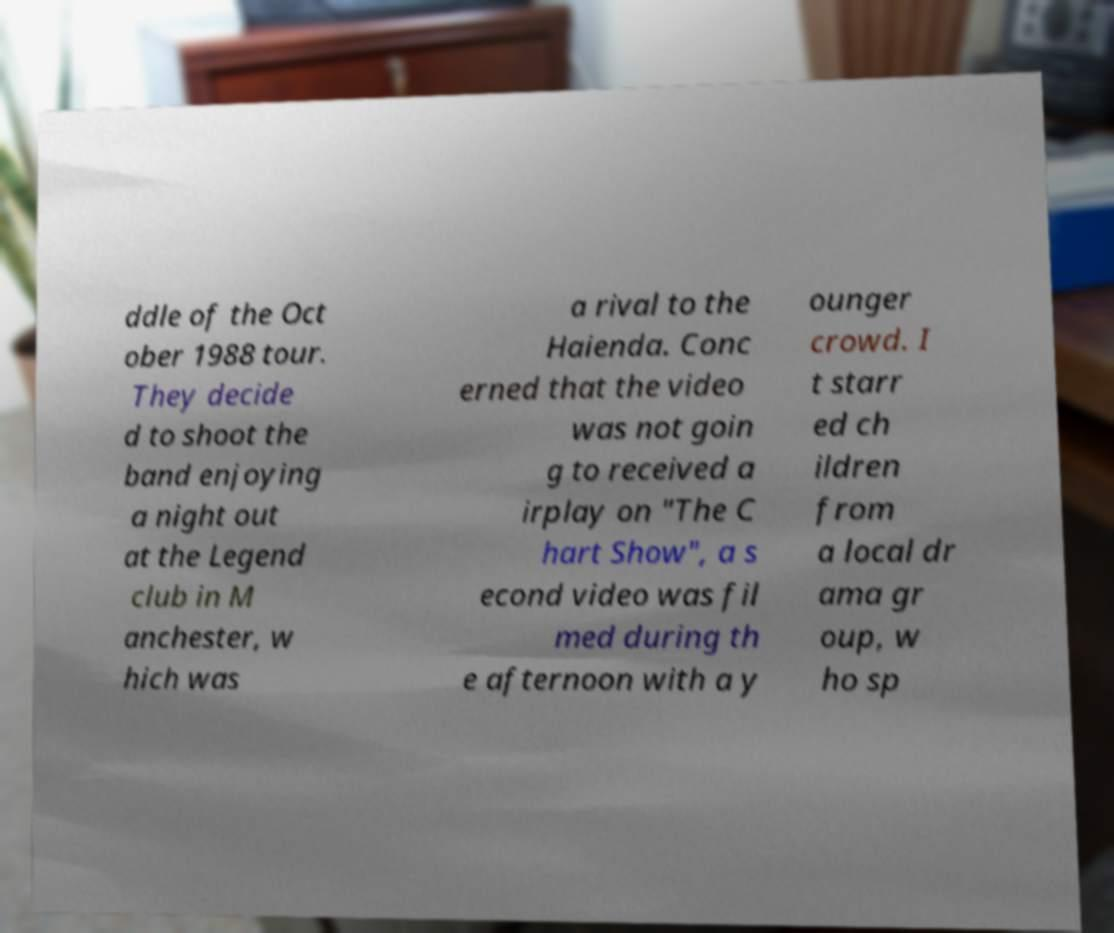Please identify and transcribe the text found in this image. ddle of the Oct ober 1988 tour. They decide d to shoot the band enjoying a night out at the Legend club in M anchester, w hich was a rival to the Haienda. Conc erned that the video was not goin g to received a irplay on "The C hart Show", a s econd video was fil med during th e afternoon with a y ounger crowd. I t starr ed ch ildren from a local dr ama gr oup, w ho sp 